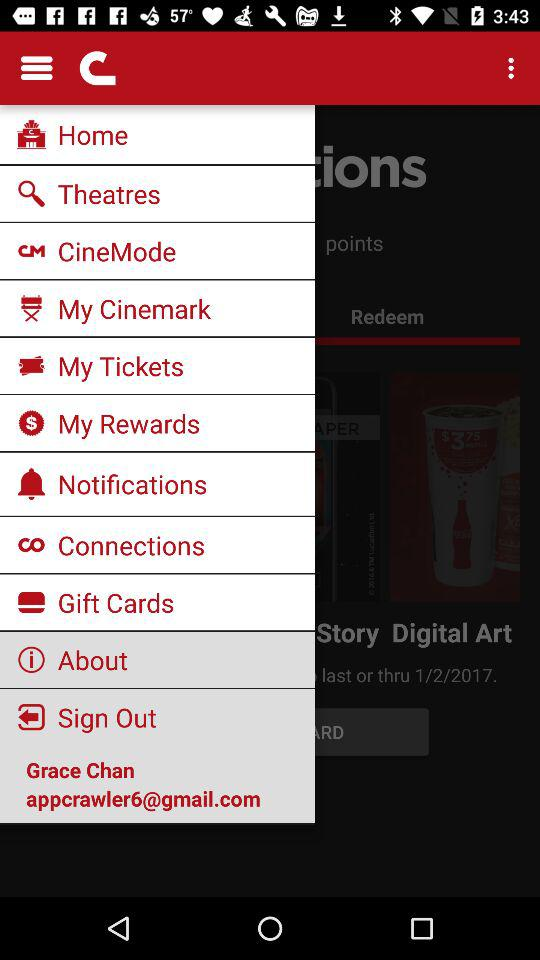What is the name of the user? The name of the user is Grace Chan. 